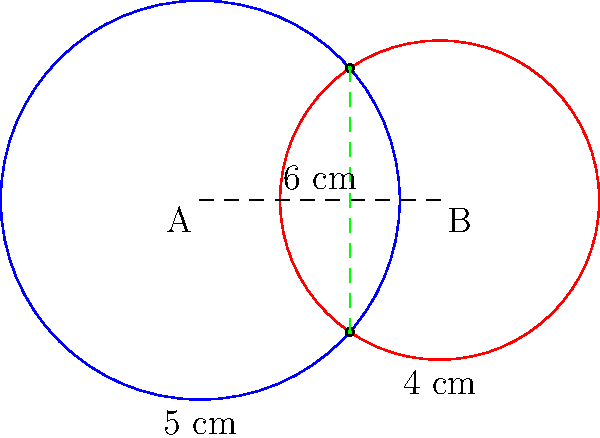Two circular moisture-wicking zones on a high-performance garment intersect as shown in the diagram. Zone A has a radius of 5 cm, while Zone B has a radius of 4 cm. The centers of these zones are 6 cm apart. Calculate the area of the overlapping region where both moisture-wicking zones are active. To find the area of the overlapping region, we need to follow these steps:

1) First, we need to find the angle subtended by the chord of intersection at the center of each circle. Let's call these angles $\theta_1$ and $\theta_2$ for circles A and B respectively.

2) We can find these angles using the cosine law:

   For circle A: $\cos(\frac{\theta_1}{2}) = \frac{5^2 + 6^2 - 4^2}{2 * 5 * 6} = \frac{37}{60}$
   For circle B: $\cos(\frac{\theta_2}{2}) = \frac{4^2 + 6^2 - 5^2}{2 * 4 * 6} = \frac{11}{24}$

3) Taking the inverse cosine:
   $\theta_1 = 2 * \arccos(\frac{37}{60}) \approx 1.8272$ radians
   $\theta_2 = 2 * \arccos(\frac{11}{24}) \approx 2.0944$ radians

4) The area of the overlapping region is the sum of the areas of the two circular sectors minus the area of the rhombus formed by the radii to the intersection points:

   Area = $\frac{1}{2}r_1^2\theta_1 + \frac{1}{2}r_2^2\theta_2 - (r_1^2\sin(\frac{\theta_1}{2}) + r_2^2\sin(\frac{\theta_2}{2}))$

5) Substituting the values:
   Area = $\frac{1}{2}*5^2*1.8272 + \frac{1}{2}*4^2*2.0944 - (5^2\sin(\frac{1.8272}{2}) + 4^2\sin(\frac{2.0944}{2}))$
        $\approx 22.84 + 16.76 - (21.37 + 13.86)$
        $\approx 4.37$ cm²

Therefore, the area of the overlapping region is approximately 4.37 cm².
Answer: 4.37 cm² 